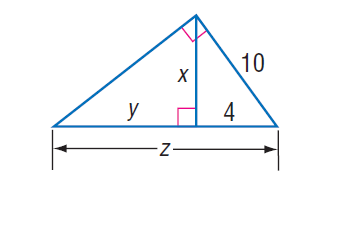Answer the mathemtical geometry problem and directly provide the correct option letter.
Question: Find z.
Choices: A: 5 B: 16 C: 21 D: 25 D 